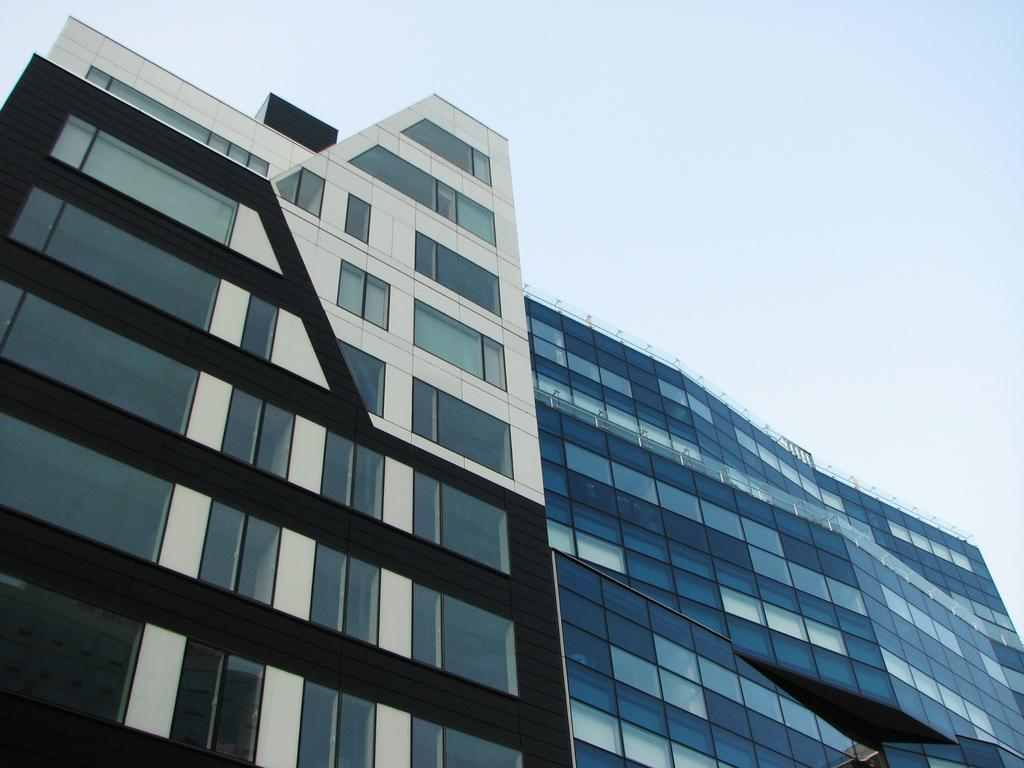What type of building is visible in the image? There is a glass building in the image. What can be seen in the background of the image? The sky is white in color in the background of the image. How many birds are flying in front of the glass building in the image? There are no birds visible in the image; it only features a glass building and a white sky in the background. 